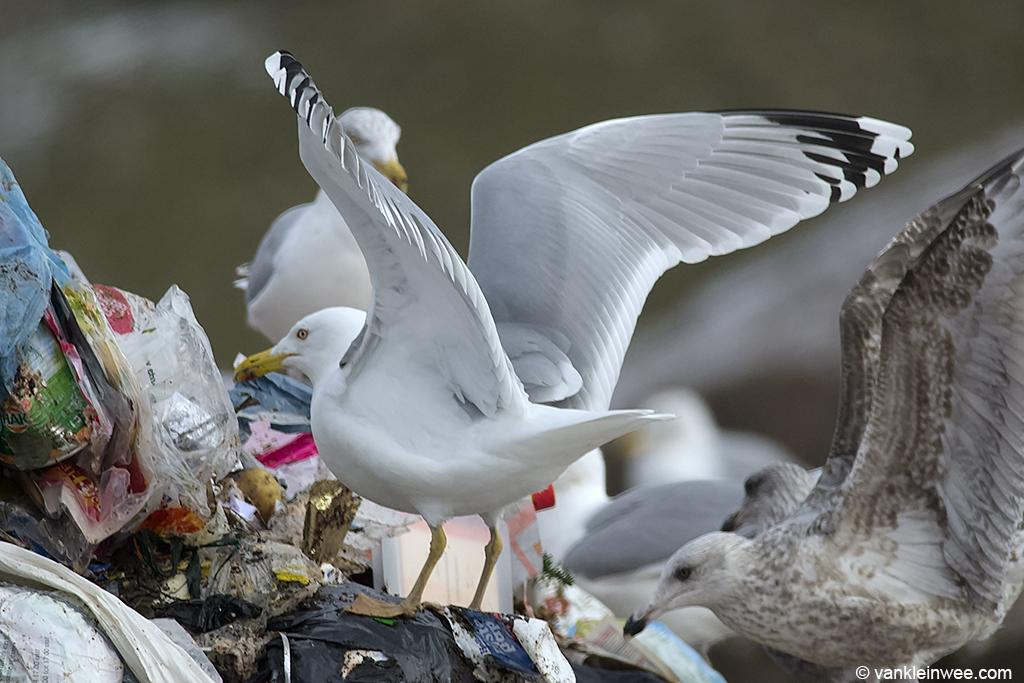What type of animals can be seen in the image? There are birds in the image. What can be seen in the background of the image? There is waste in the background of the image. How would you describe the background of the image? The background is blurred. Where is the text located in the image? There is text in the bottom right of the image. What type of zoo can be seen in the background of the image? There is no zoo present in the image; it only shows birds and waste in the background. Can you provide an example of a similar scene to this image? The image is unique and cannot be compared to any other specific scene. 